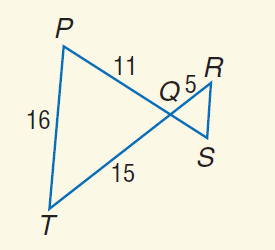Question: Find the perimeter of \triangle Q R S if \triangle Q R S \sim \triangle Q T P.
Choices:
A. 9
B. 14
C. 21
D. 42
Answer with the letter. Answer: B 